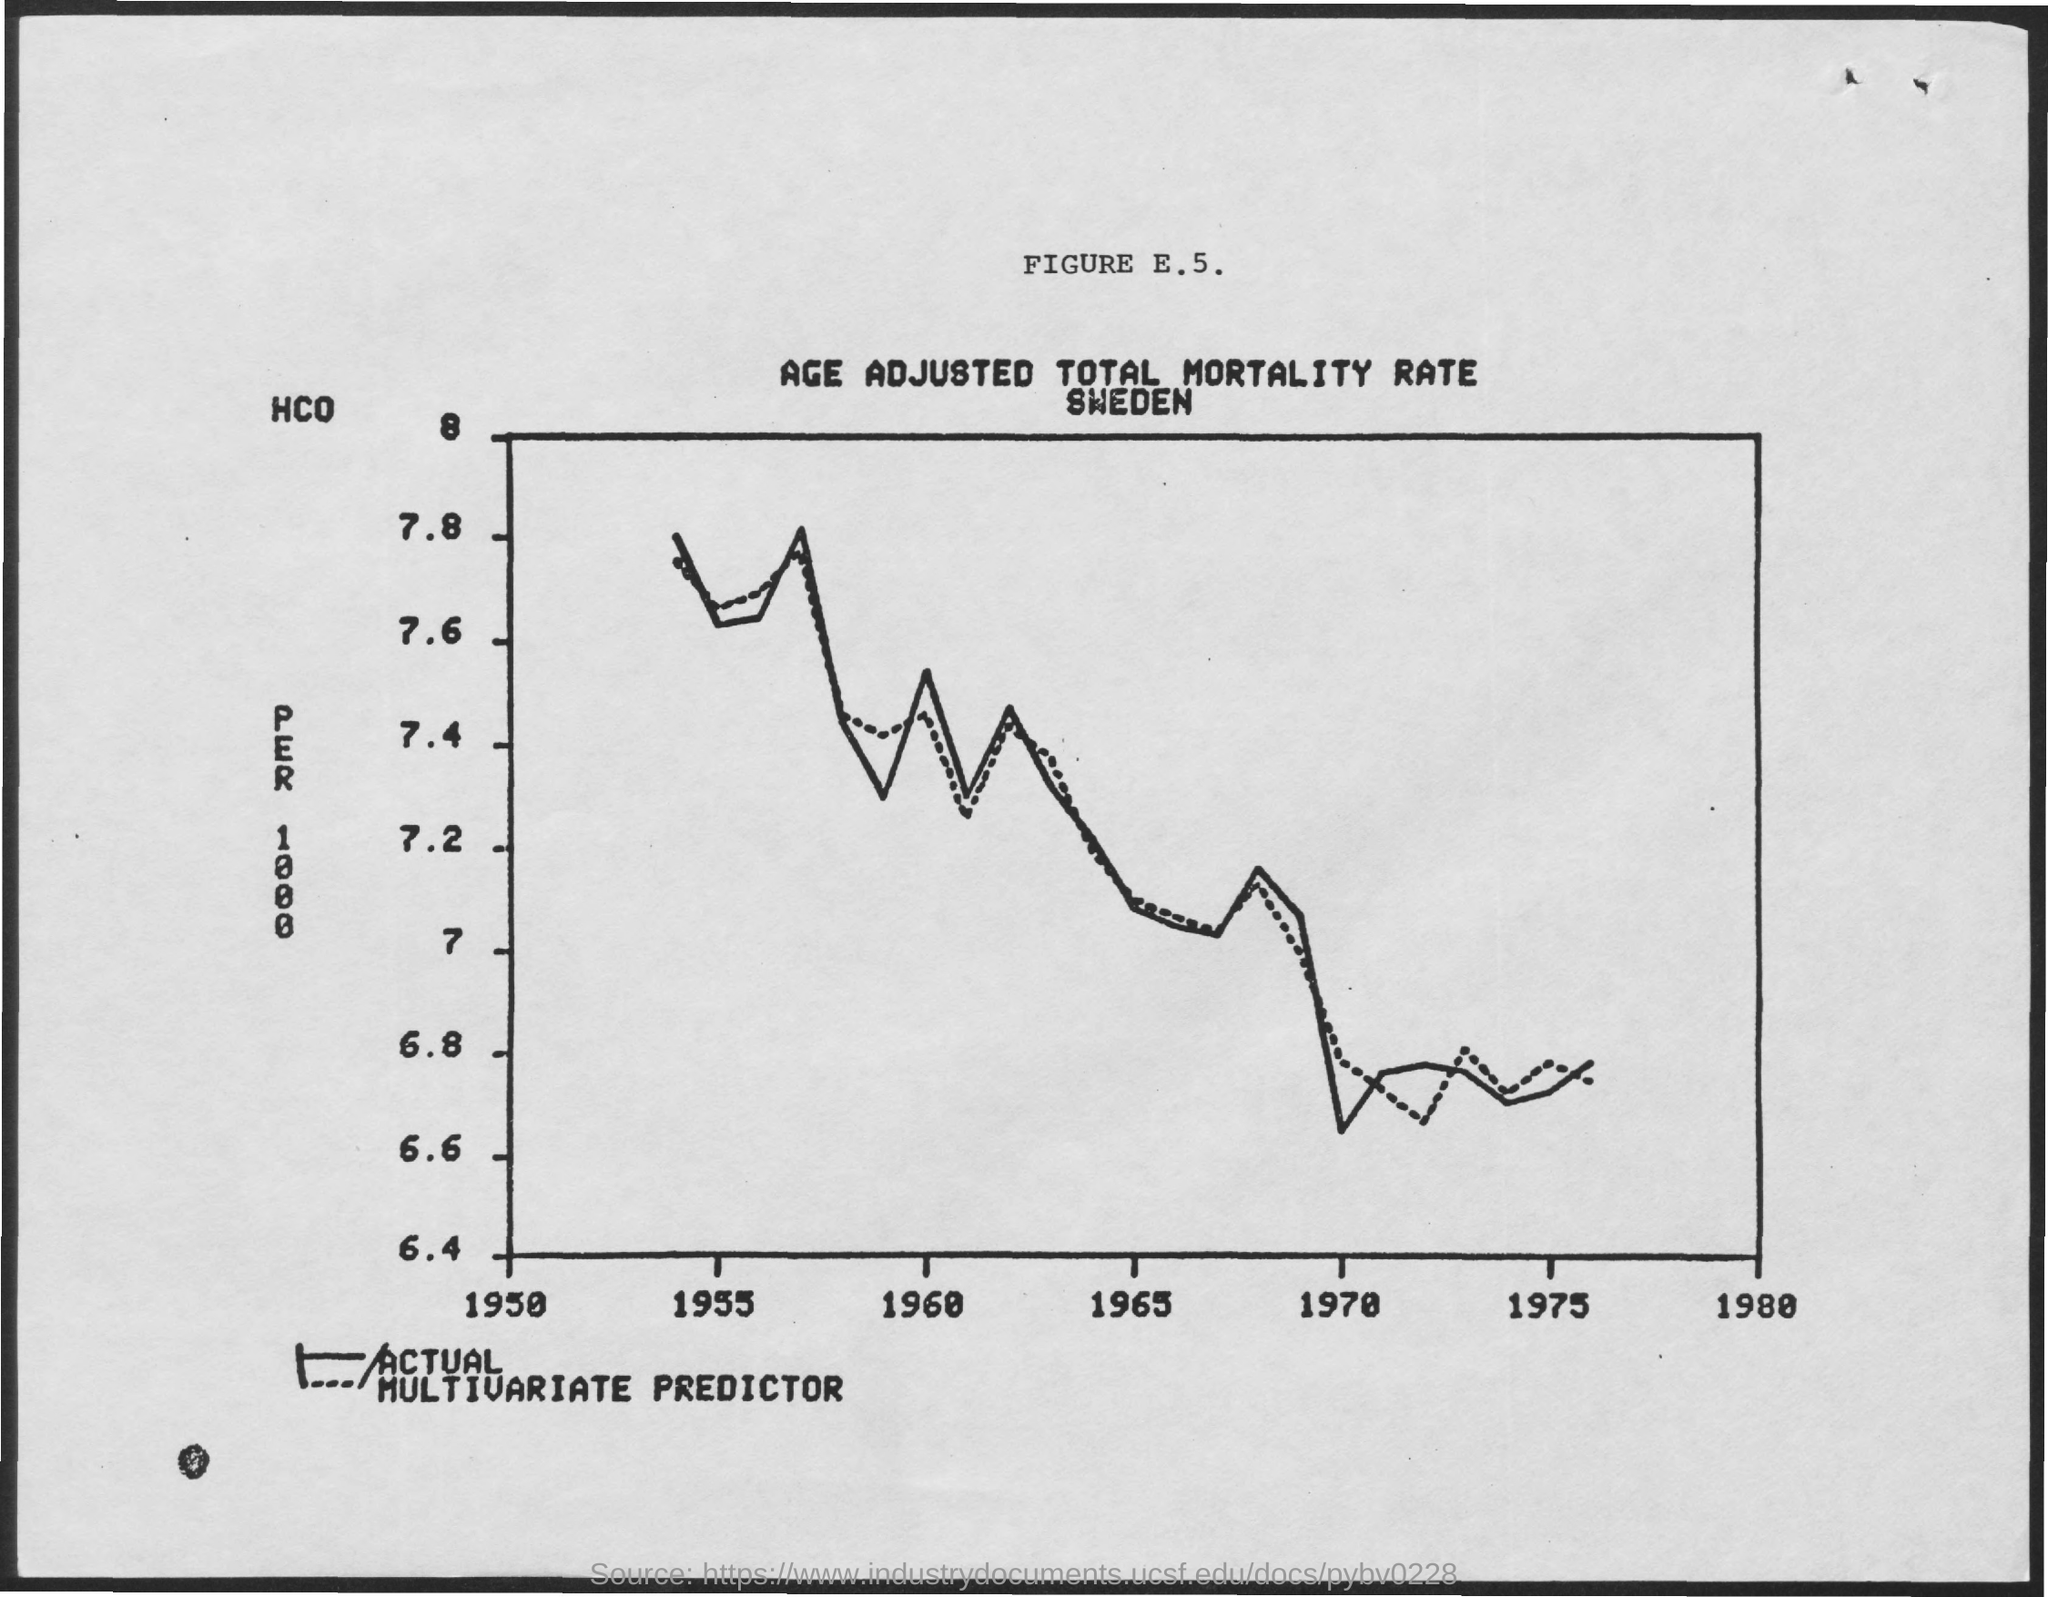Highlight a few significant elements in this photo. The title of FIGURE E.5 is 'Age-Adjusted Total Mortality Rate in Sweden.' 